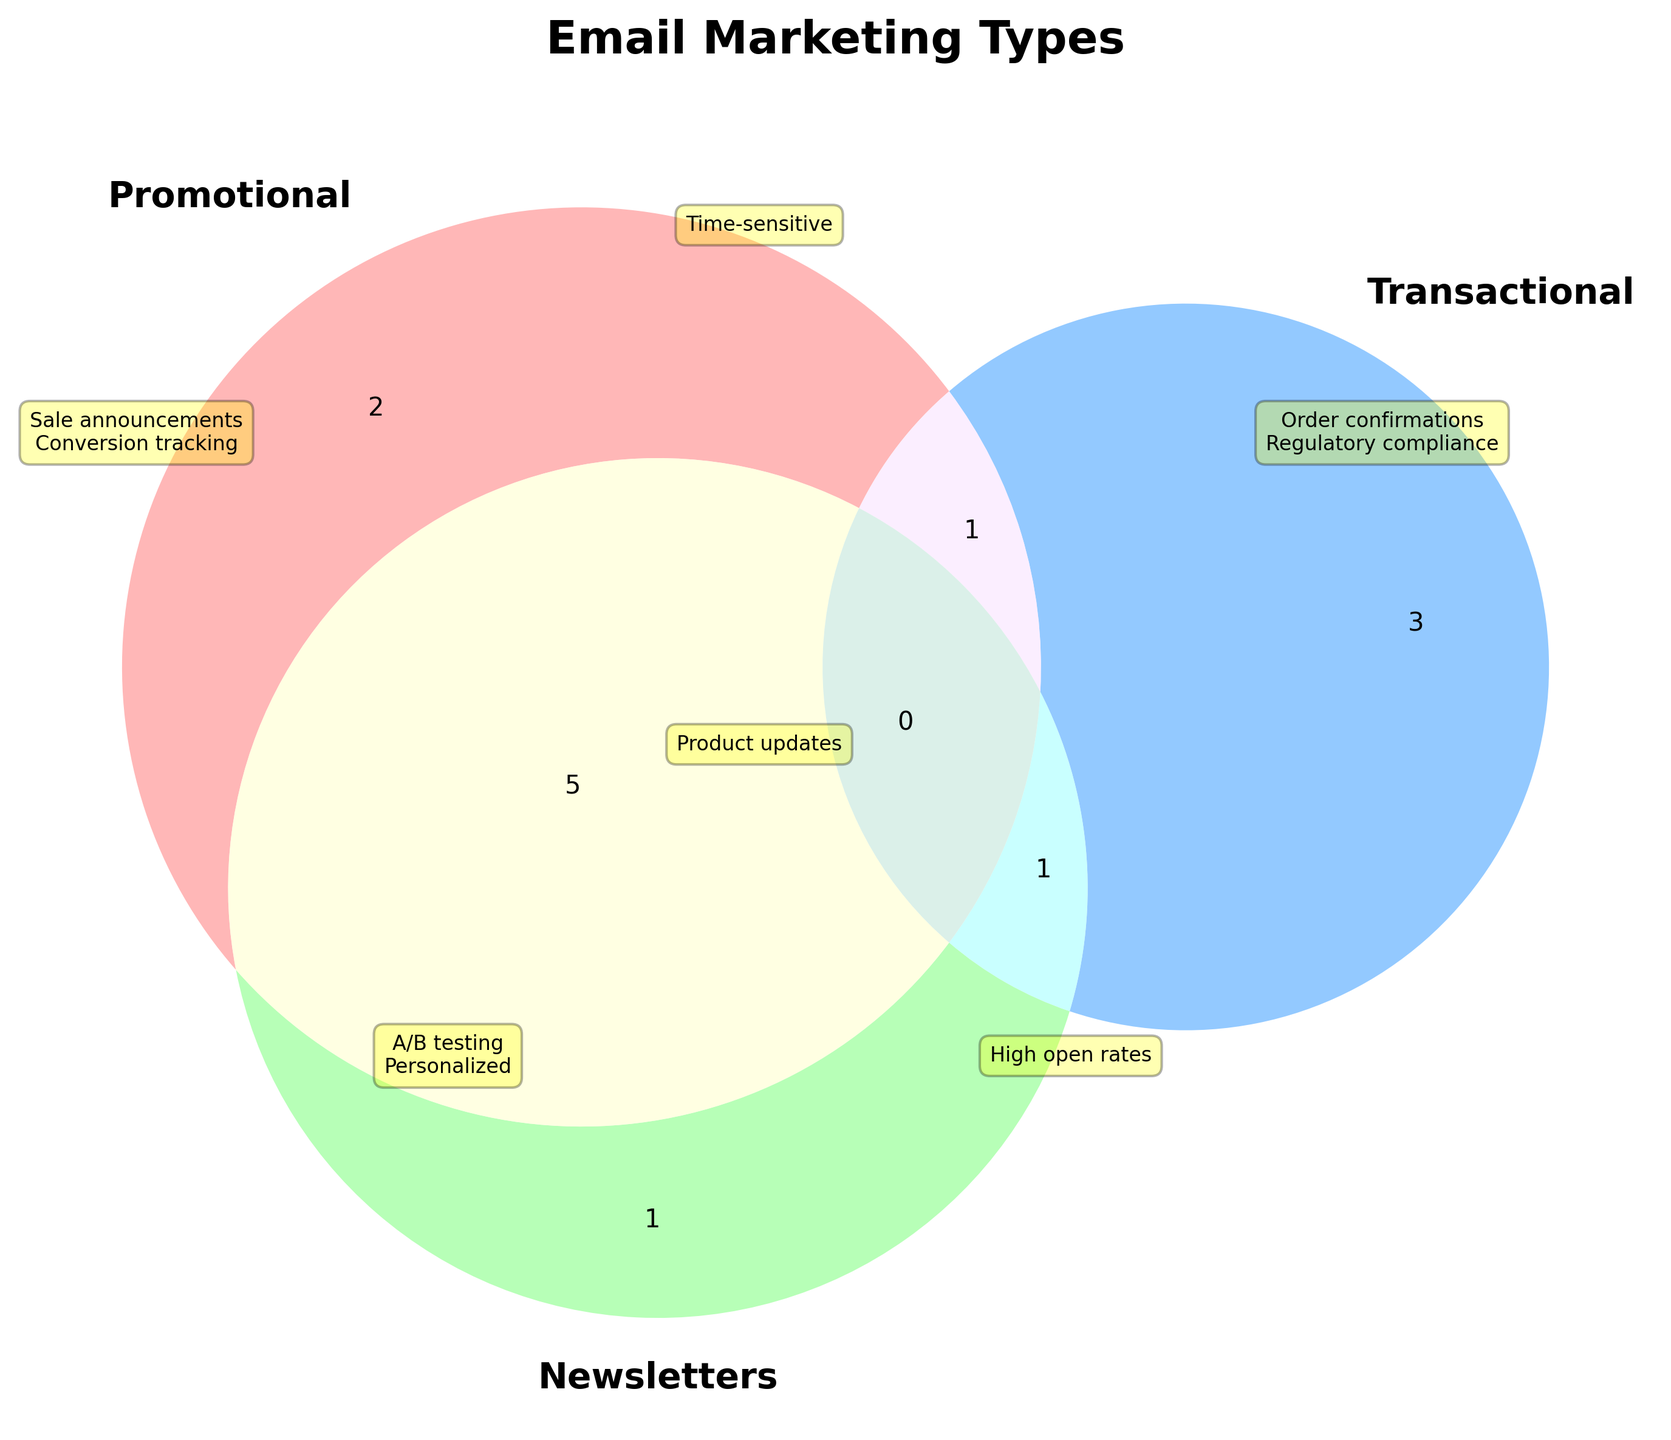What is the title of the Venn Diagram? The title is usually found at the top of the figure and is the largest text element.
Answer: Email Marketing Types Which email type has the characteristic "Brand storytelling"? Locate the "Brand storytelling" annotation and see which email type it is associated with.
Answer: Newsletters What are the shared characteristics between Promotional and Newsletters email types? Find the overlapping area between Promotional and Newsletters and read the annotations within this section.
Answer: A/B testing, Personalized Which email types have "High open rates"? Identify the annotation "High open rates" and see which email types intersect in this section.
Answer: Transactional, Newsletters How many characteristics are shared by all three email types? Count the number of characteristics in the overlapping area of all three circles.
Answer: 1 What characteristic is unique to Promotional emails? Look at the characteristics in the Promotional circle that are not in any overlapping areas.
Answer: Sale announcements, Conversion tracking Which email type focuses on "Automated triggers"? Locate the "Automated triggers" annotation and see which email type it is associated with.
Answer: Transactional What is the common feature between Transactional and Newsletters but not Promotional? Find the overlapping area between Transactional and Newsletters and read the annotations within this section.
Answer: High open rates Do Promotional emails have "Order confirmations" as a characteristic? Check if "Order confirmations" is in the Promotional circle or in any overlapping regions involving Promotional.
Answer: No Which characteristic is shared between Promotional and Transactional emails but not included in Newsletters? Find the overlapping area between Promotional and Transactional and read the annotations within this section.
Answer: Time-sensitive 